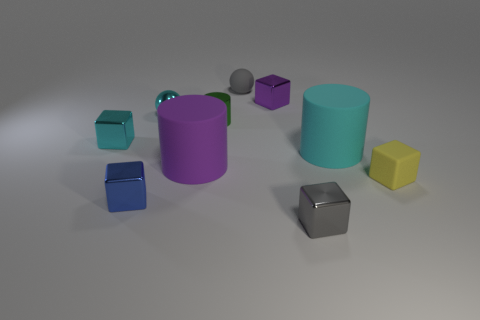Subtract all gray cubes. How many cubes are left? 4 Subtract all green cylinders. How many cylinders are left? 2 Subtract 3 cubes. How many cubes are left? 2 Subtract all yellow balls. How many green cylinders are left? 1 Subtract all large purple metal spheres. Subtract all purple metallic blocks. How many objects are left? 9 Add 3 small gray metallic cubes. How many small gray metallic cubes are left? 4 Add 1 large blue cylinders. How many large blue cylinders exist? 1 Subtract 0 green spheres. How many objects are left? 10 Subtract all cylinders. How many objects are left? 7 Subtract all red cubes. Subtract all red cylinders. How many cubes are left? 5 